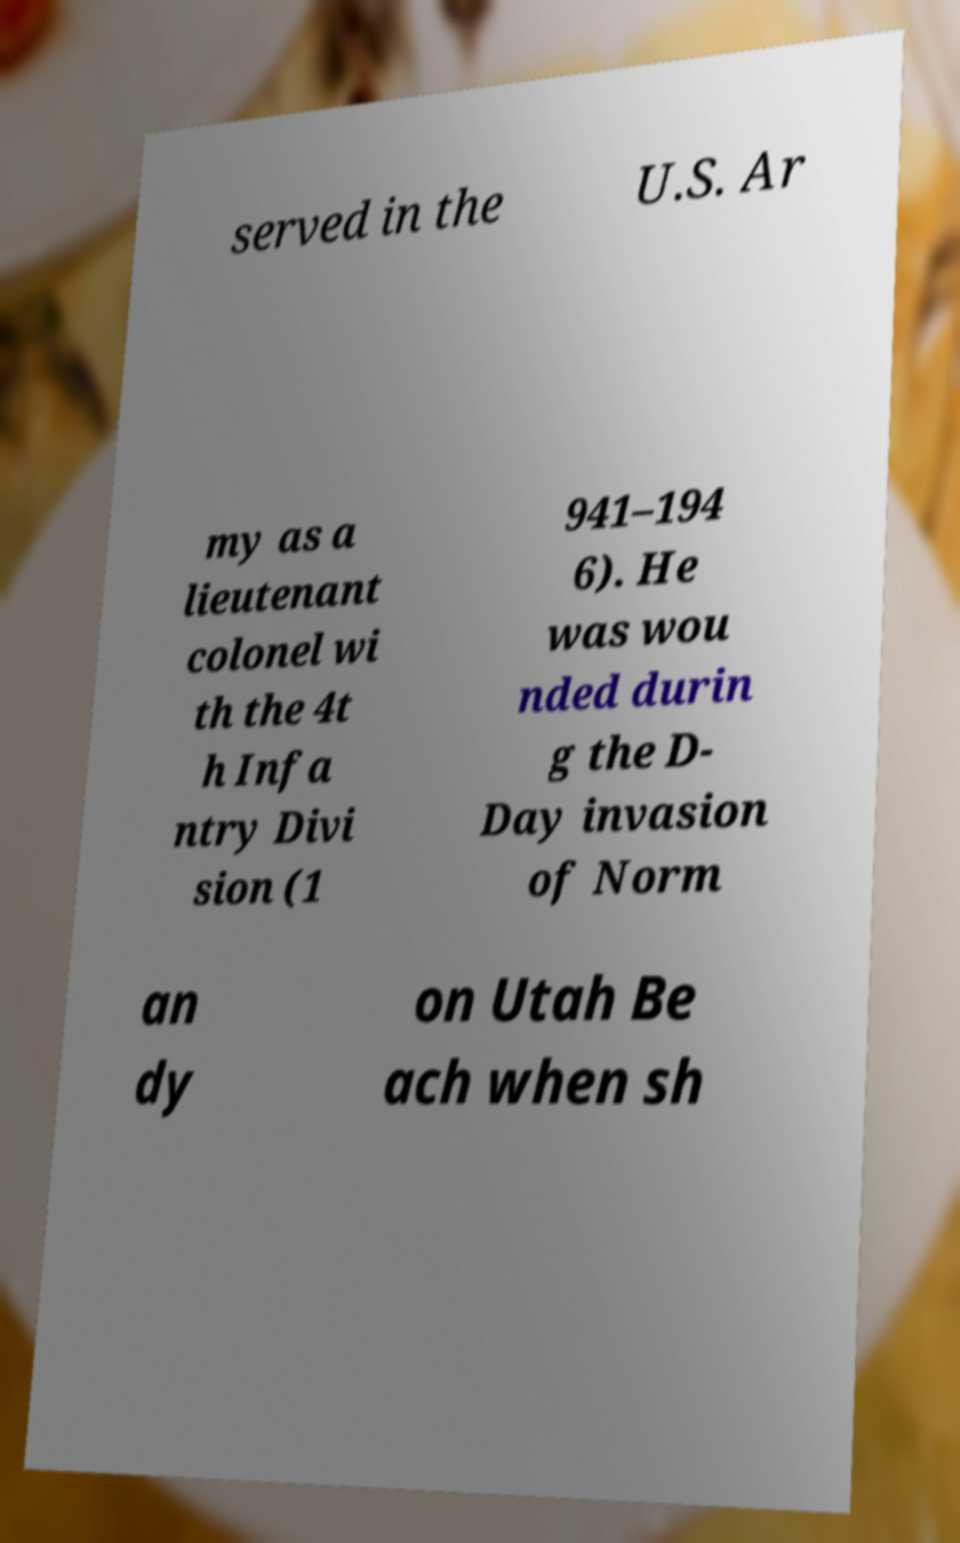Can you read and provide the text displayed in the image?This photo seems to have some interesting text. Can you extract and type it out for me? served in the U.S. Ar my as a lieutenant colonel wi th the 4t h Infa ntry Divi sion (1 941–194 6). He was wou nded durin g the D- Day invasion of Norm an dy on Utah Be ach when sh 